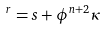<formula> <loc_0><loc_0><loc_500><loc_500>^ { r } = s + \phi ^ { n + 2 } \kappa</formula> 